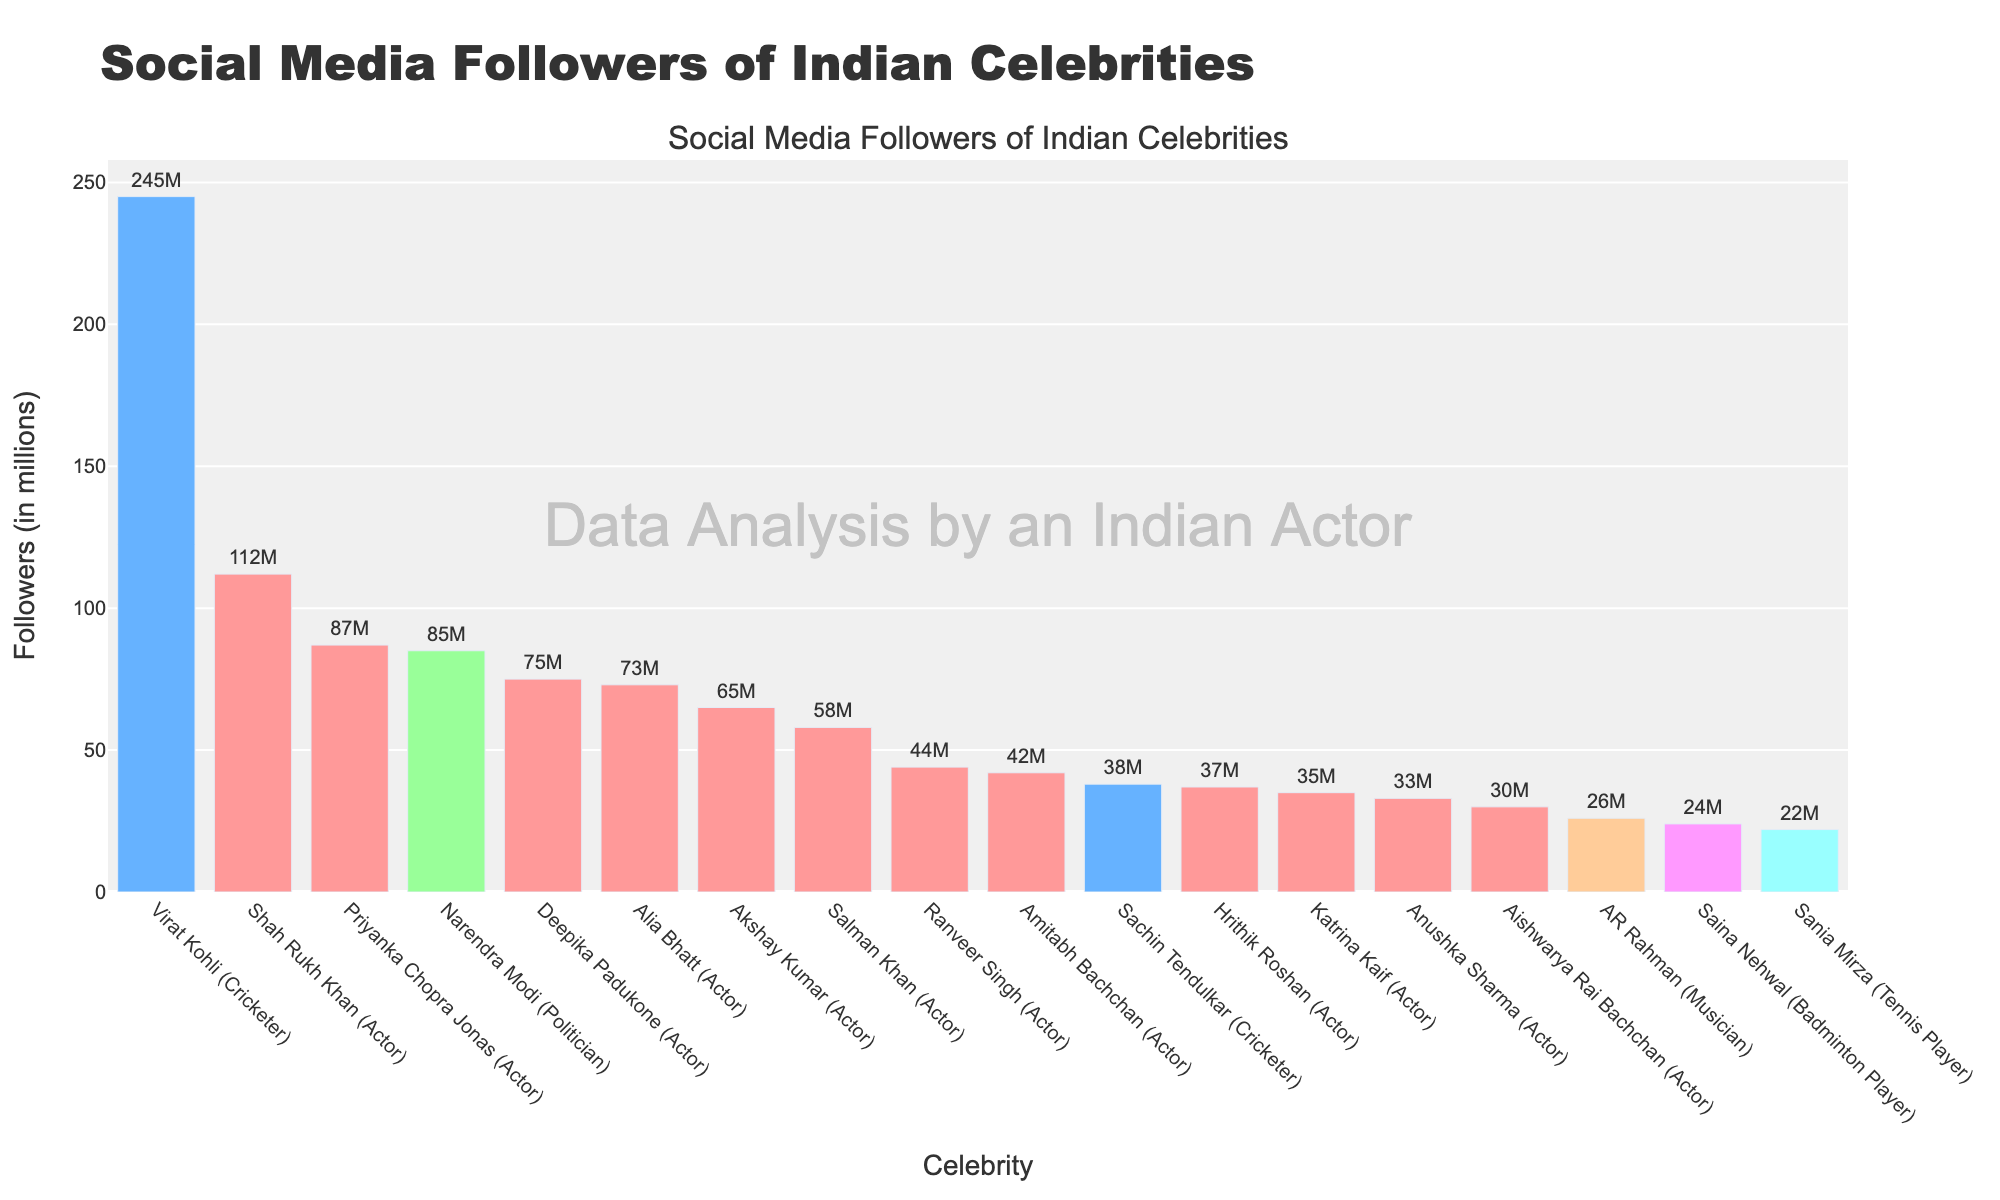What is the difference in social media followers between Virat Kohli and Shah Rukh Khan? First, identify the follower counts for both celebrities from the chart. Virat Kohli has 245 million followers, while Shah Rukh Khan has 112 million followers. Subtract Shah Rukh Khan's followers from Virat Kohli's followers: 245M - 112M = 133M
Answer: 133M Which actor has the highest number of social media followers? Refer to the bars associated with actors in the chart. Shah Rukh Khan has the highest number of social media followers among actors with 112 million.
Answer: Shah Rukh Khan How many followers do the top three most-followed celebrities have in total? Identify the top three most-followed celebrities from the chart: Virat Kohli (245M), Shah Rukh Khan (112M), and Priyanka Chopra Jonas (87M). Sum their followers: 245M + 112M + 87M = 444M
Answer: 444M By how many millions do Alia Bhatt's followers exceed Sachin Tendulkar's followers? Identify the follower counts for Alia Bhatt (73M) and Sachin Tendulkar (38M). Calculate the difference: 73M - 38M = 35M
Answer: 35M What is the combined follower count of the actors ranked 4th and 5th in the list? Identify the 4th and 5th ranked actors by followers: Deepika Padukone (75M) and Alia Bhatt (73M). Sum their followers: 75M + 73M = 148M
Answer: 148M Who has more followers, Narendra Modi or Deepika Padukone, and by how much? Identify the follower counts for Narendra Modi (85M) and Deepika Padukone (75M). Narendra Modi has more followers than Deepika Padukone. Calculate the difference: 85M - 75M = 10M
Answer: Narendra Modi, 10M Which type of celebrity, actor or cricketer, has more followers on average? Identify the follower counts for actors (112M, 87M, 75M, 73M, 65M, 58M, 44M, 42M, 37M, 35M, 33M, 30M) and for cricketers (245M, 38M). Calculate the average for actors: (112 + 87 + 75 + 73 + 65 + 58 + 44 + 42 + 37 + 35 + 33 + 30) / 12 = 58.25M. Calculate the average for cricketers: (245 + 38) / 2 = 141.5M. Cricketers have a higher average follower count.
Answer: Cricketers, 141.5M What color represents musicians in the chart? Identify the color associated with the musician AR Rahman. The bar representing AR Rahman, a musician, is colored light brown (peach).
Answer: Light brown (peach) How many celebrities have followers between 30 million and 60 million? Identify celebrities with follower counts within the specified range from the chart: Akshay Kumar (65M), Salman Khan (58M), Ranveer Singh (44M), Amitabh Bachchan (42M), and Sachin Tendulkar (38M). Count the number of these celebrities: 5
Answer: 5 